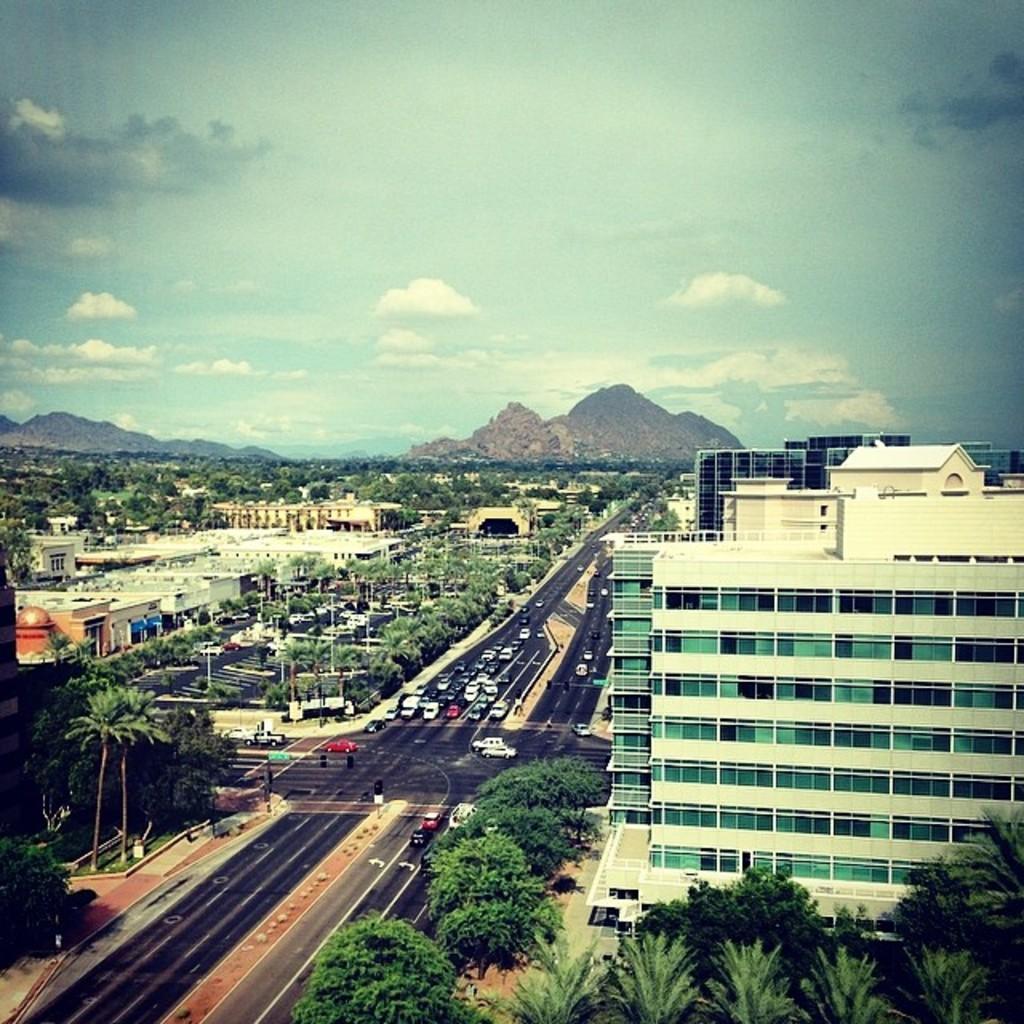Please provide a concise description of this image. In this image, we can see some buildings and trees. There are vehicles on the road which is in the middle of the image. In the background of the image, there is a sky. 